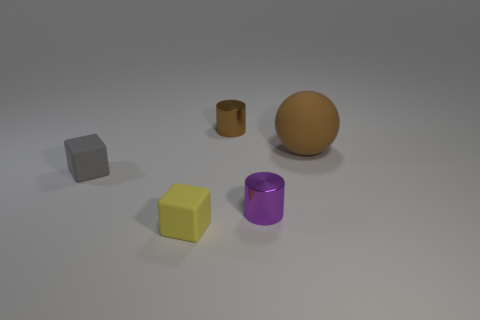Add 1 tiny brown shiny cylinders. How many objects exist? 6 Subtract all purple cylinders. How many cylinders are left? 1 Subtract all cubes. How many objects are left? 3 Subtract all green metallic spheres. Subtract all tiny things. How many objects are left? 1 Add 2 shiny things. How many shiny things are left? 4 Add 1 large red metal cylinders. How many large red metal cylinders exist? 1 Subtract 0 cyan balls. How many objects are left? 5 Subtract all purple cylinders. Subtract all gray blocks. How many cylinders are left? 1 Subtract all gray balls. How many gray cubes are left? 1 